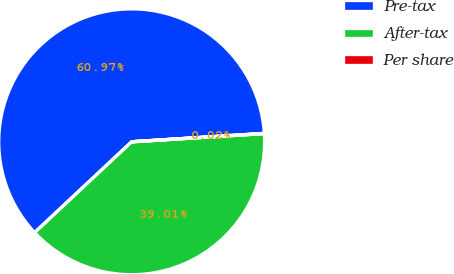Convert chart to OTSL. <chart><loc_0><loc_0><loc_500><loc_500><pie_chart><fcel>Pre-tax<fcel>After-tax<fcel>Per share<nl><fcel>60.96%<fcel>39.01%<fcel>0.02%<nl></chart> 